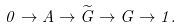<formula> <loc_0><loc_0><loc_500><loc_500>0 \rightarrow A \rightarrow \widetilde { G } \rightarrow G \rightarrow 1 .</formula> 